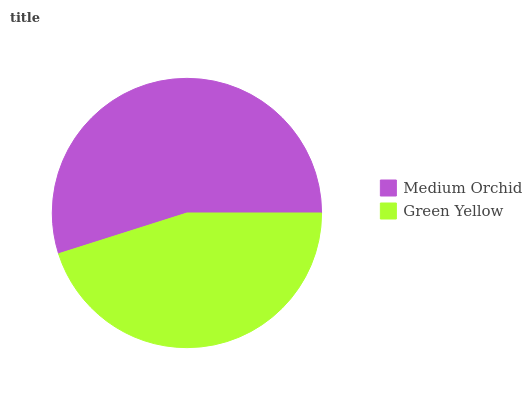Is Green Yellow the minimum?
Answer yes or no. Yes. Is Medium Orchid the maximum?
Answer yes or no. Yes. Is Green Yellow the maximum?
Answer yes or no. No. Is Medium Orchid greater than Green Yellow?
Answer yes or no. Yes. Is Green Yellow less than Medium Orchid?
Answer yes or no. Yes. Is Green Yellow greater than Medium Orchid?
Answer yes or no. No. Is Medium Orchid less than Green Yellow?
Answer yes or no. No. Is Medium Orchid the high median?
Answer yes or no. Yes. Is Green Yellow the low median?
Answer yes or no. Yes. Is Green Yellow the high median?
Answer yes or no. No. Is Medium Orchid the low median?
Answer yes or no. No. 